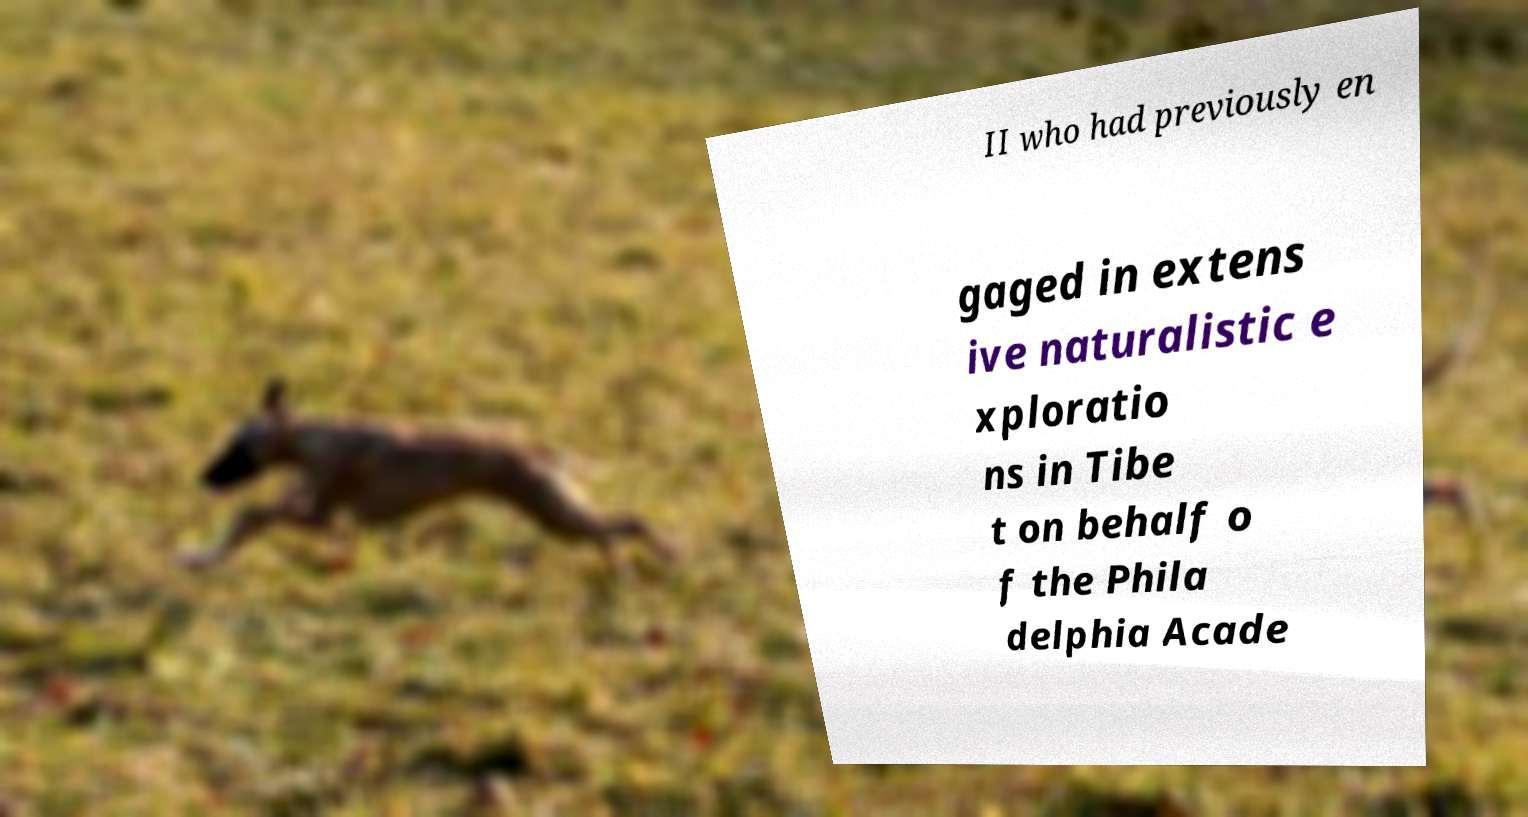Can you accurately transcribe the text from the provided image for me? II who had previously en gaged in extens ive naturalistic e xploratio ns in Tibe t on behalf o f the Phila delphia Acade 